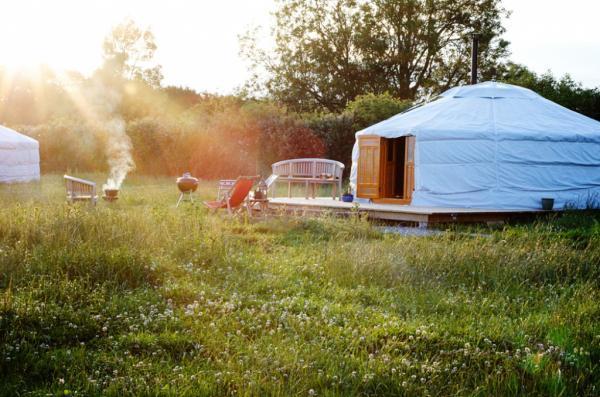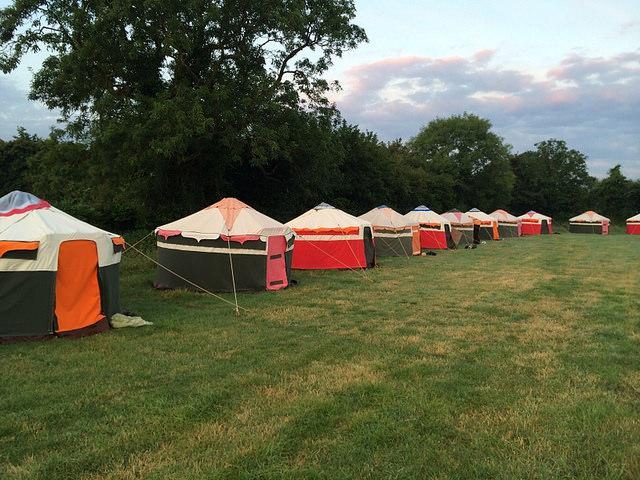The first image is the image on the left, the second image is the image on the right. Considering the images on both sides, is "Exactly three round house structures are shown." valid? Answer yes or no. No. The first image is the image on the left, the second image is the image on the right. Considering the images on both sides, is "An image includes at least four cone-topped tents in a row." valid? Answer yes or no. Yes. 